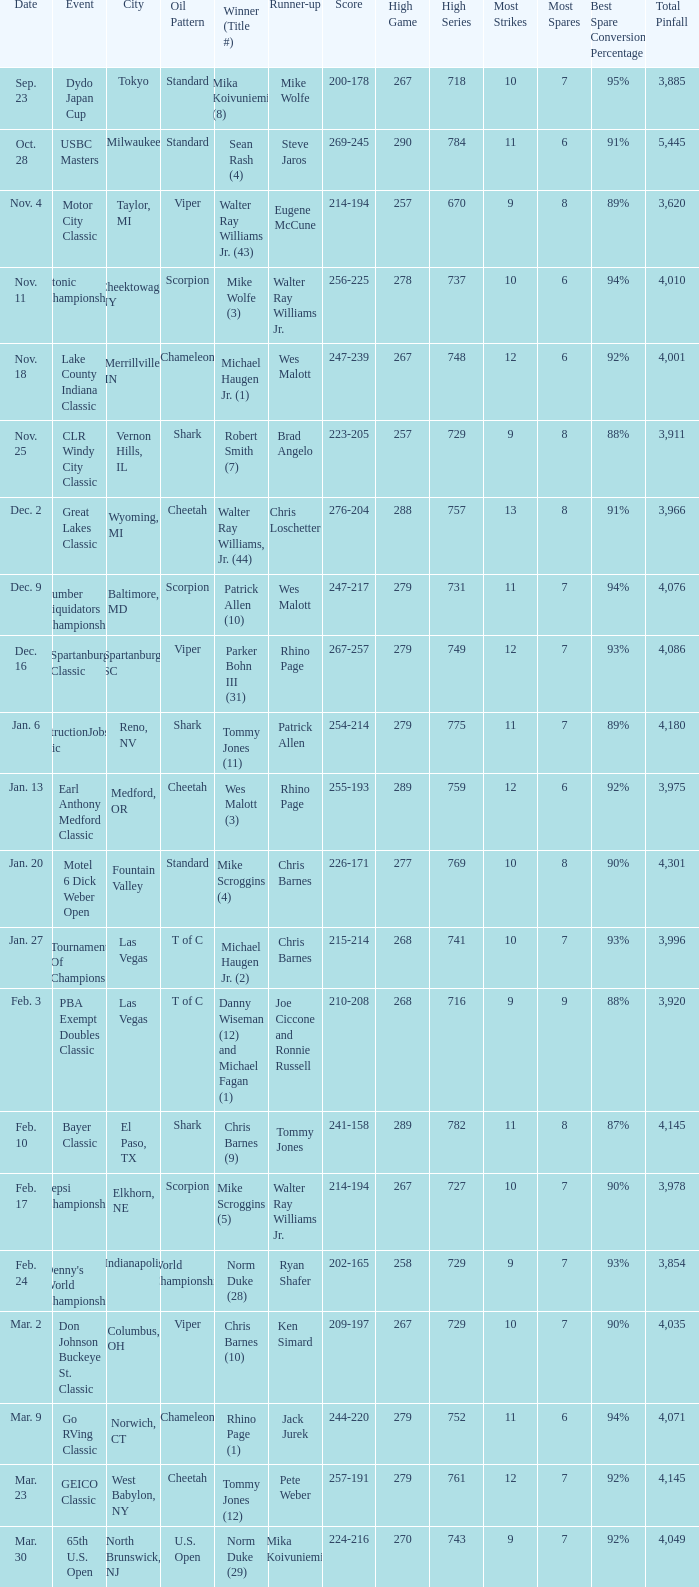Name the Event which has a Score of 209-197? Don Johnson Buckeye St. Classic. 